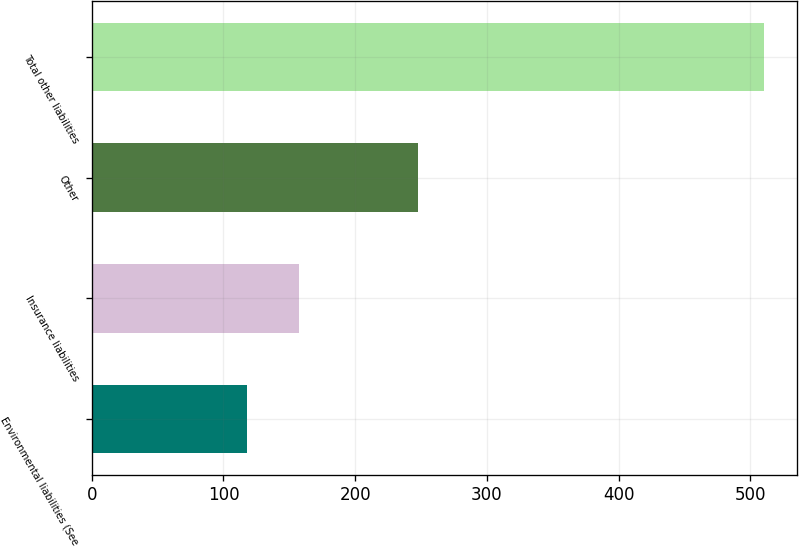Convert chart. <chart><loc_0><loc_0><loc_500><loc_500><bar_chart><fcel>Environmental liabilities (See<fcel>Insurance liabilities<fcel>Other<fcel>Total other liabilities<nl><fcel>118<fcel>157.2<fcel>248<fcel>510<nl></chart> 